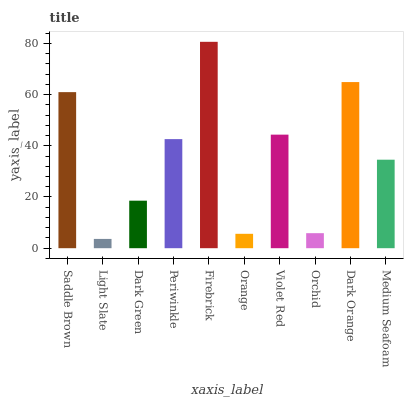Is Dark Green the minimum?
Answer yes or no. No. Is Dark Green the maximum?
Answer yes or no. No. Is Dark Green greater than Light Slate?
Answer yes or no. Yes. Is Light Slate less than Dark Green?
Answer yes or no. Yes. Is Light Slate greater than Dark Green?
Answer yes or no. No. Is Dark Green less than Light Slate?
Answer yes or no. No. Is Periwinkle the high median?
Answer yes or no. Yes. Is Medium Seafoam the low median?
Answer yes or no. Yes. Is Saddle Brown the high median?
Answer yes or no. No. Is Dark Orange the low median?
Answer yes or no. No. 